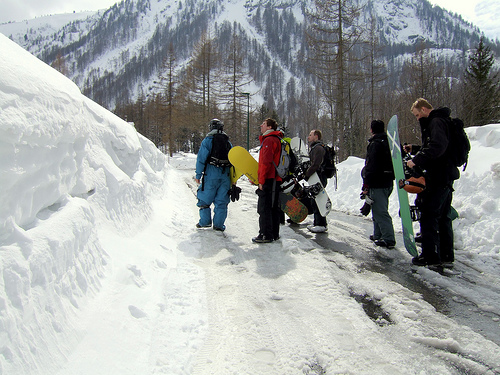<image>
Can you confirm if the snowboard is on the snow? No. The snowboard is not positioned on the snow. They may be near each other, but the snowboard is not supported by or resting on top of the snow. 